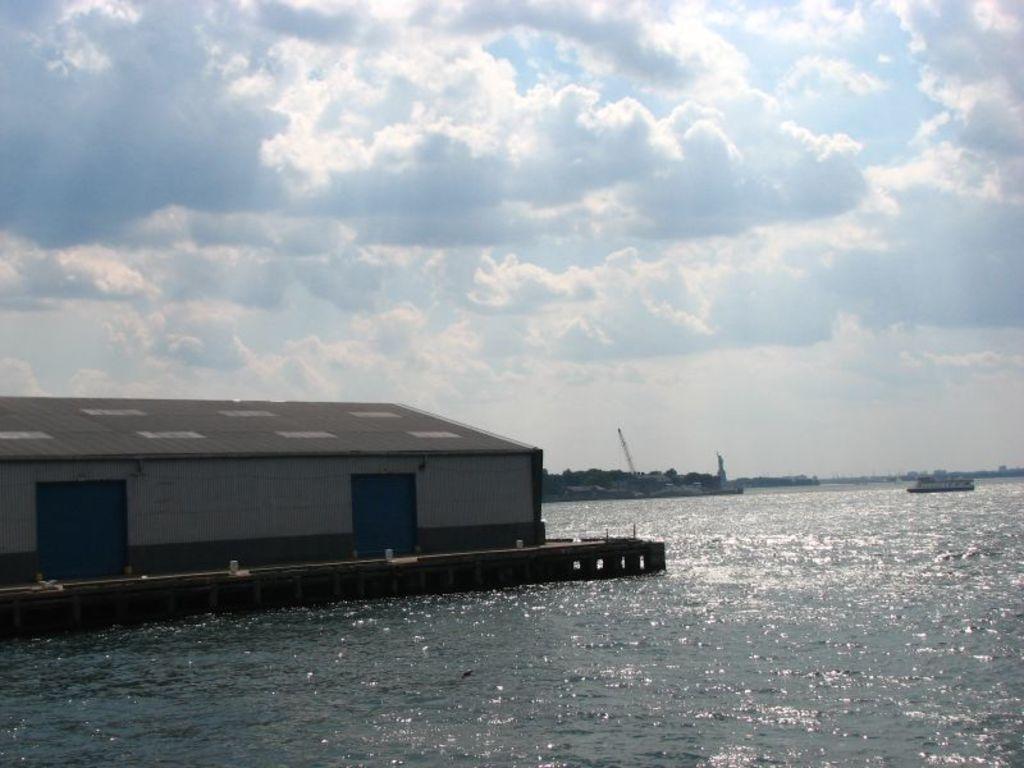Please provide a concise description of this image. In this image I can see a house on the water. background I can see few boats and sky is in blue and white color. 